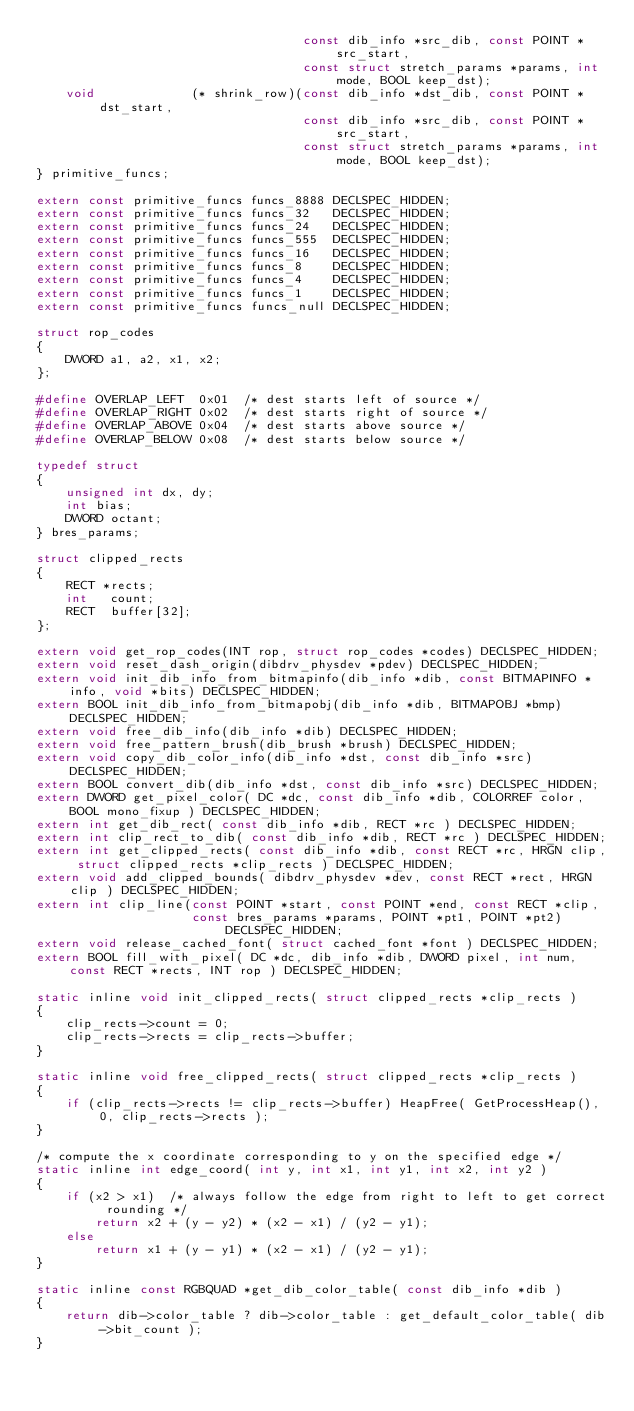<code> <loc_0><loc_0><loc_500><loc_500><_C_>                                    const dib_info *src_dib, const POINT *src_start,
                                    const struct stretch_params *params, int mode, BOOL keep_dst);
    void             (* shrink_row)(const dib_info *dst_dib, const POINT *dst_start,
                                    const dib_info *src_dib, const POINT *src_start,
                                    const struct stretch_params *params, int mode, BOOL keep_dst);
} primitive_funcs;

extern const primitive_funcs funcs_8888 DECLSPEC_HIDDEN;
extern const primitive_funcs funcs_32   DECLSPEC_HIDDEN;
extern const primitive_funcs funcs_24   DECLSPEC_HIDDEN;
extern const primitive_funcs funcs_555  DECLSPEC_HIDDEN;
extern const primitive_funcs funcs_16   DECLSPEC_HIDDEN;
extern const primitive_funcs funcs_8    DECLSPEC_HIDDEN;
extern const primitive_funcs funcs_4    DECLSPEC_HIDDEN;
extern const primitive_funcs funcs_1    DECLSPEC_HIDDEN;
extern const primitive_funcs funcs_null DECLSPEC_HIDDEN;

struct rop_codes
{
    DWORD a1, a2, x1, x2;
};

#define OVERLAP_LEFT  0x01  /* dest starts left of source */
#define OVERLAP_RIGHT 0x02  /* dest starts right of source */
#define OVERLAP_ABOVE 0x04  /* dest starts above source */
#define OVERLAP_BELOW 0x08  /* dest starts below source */

typedef struct
{
    unsigned int dx, dy;
    int bias;
    DWORD octant;
} bres_params;

struct clipped_rects
{
    RECT *rects;
    int   count;
    RECT  buffer[32];
};

extern void get_rop_codes(INT rop, struct rop_codes *codes) DECLSPEC_HIDDEN;
extern void reset_dash_origin(dibdrv_physdev *pdev) DECLSPEC_HIDDEN;
extern void init_dib_info_from_bitmapinfo(dib_info *dib, const BITMAPINFO *info, void *bits) DECLSPEC_HIDDEN;
extern BOOL init_dib_info_from_bitmapobj(dib_info *dib, BITMAPOBJ *bmp) DECLSPEC_HIDDEN;
extern void free_dib_info(dib_info *dib) DECLSPEC_HIDDEN;
extern void free_pattern_brush(dib_brush *brush) DECLSPEC_HIDDEN;
extern void copy_dib_color_info(dib_info *dst, const dib_info *src) DECLSPEC_HIDDEN;
extern BOOL convert_dib(dib_info *dst, const dib_info *src) DECLSPEC_HIDDEN;
extern DWORD get_pixel_color( DC *dc, const dib_info *dib, COLORREF color, BOOL mono_fixup ) DECLSPEC_HIDDEN;
extern int get_dib_rect( const dib_info *dib, RECT *rc ) DECLSPEC_HIDDEN;
extern int clip_rect_to_dib( const dib_info *dib, RECT *rc ) DECLSPEC_HIDDEN;
extern int get_clipped_rects( const dib_info *dib, const RECT *rc, HRGN clip, struct clipped_rects *clip_rects ) DECLSPEC_HIDDEN;
extern void add_clipped_bounds( dibdrv_physdev *dev, const RECT *rect, HRGN clip ) DECLSPEC_HIDDEN;
extern int clip_line(const POINT *start, const POINT *end, const RECT *clip,
                     const bres_params *params, POINT *pt1, POINT *pt2) DECLSPEC_HIDDEN;
extern void release_cached_font( struct cached_font *font ) DECLSPEC_HIDDEN;
extern BOOL fill_with_pixel( DC *dc, dib_info *dib, DWORD pixel, int num, const RECT *rects, INT rop ) DECLSPEC_HIDDEN;

static inline void init_clipped_rects( struct clipped_rects *clip_rects )
{
    clip_rects->count = 0;
    clip_rects->rects = clip_rects->buffer;
}

static inline void free_clipped_rects( struct clipped_rects *clip_rects )
{
    if (clip_rects->rects != clip_rects->buffer) HeapFree( GetProcessHeap(), 0, clip_rects->rects );
}

/* compute the x coordinate corresponding to y on the specified edge */
static inline int edge_coord( int y, int x1, int y1, int x2, int y2 )
{
    if (x2 > x1)  /* always follow the edge from right to left to get correct rounding */
        return x2 + (y - y2) * (x2 - x1) / (y2 - y1);
    else
        return x1 + (y - y1) * (x2 - x1) / (y2 - y1);
}

static inline const RGBQUAD *get_dib_color_table( const dib_info *dib )
{
    return dib->color_table ? dib->color_table : get_default_color_table( dib->bit_count );
}
</code> 